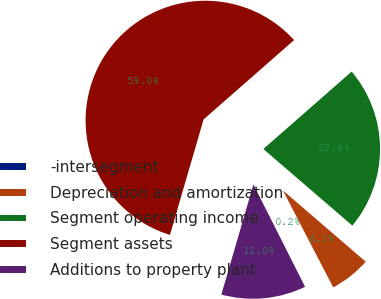Convert chart to OTSL. <chart><loc_0><loc_0><loc_500><loc_500><pie_chart><fcel>-intersegment<fcel>Depreciation and amortization<fcel>Segment operating income<fcel>Segment assets<fcel>Additions to property plant<nl><fcel>0.18%<fcel>6.07%<fcel>22.76%<fcel>59.03%<fcel>11.95%<nl></chart> 